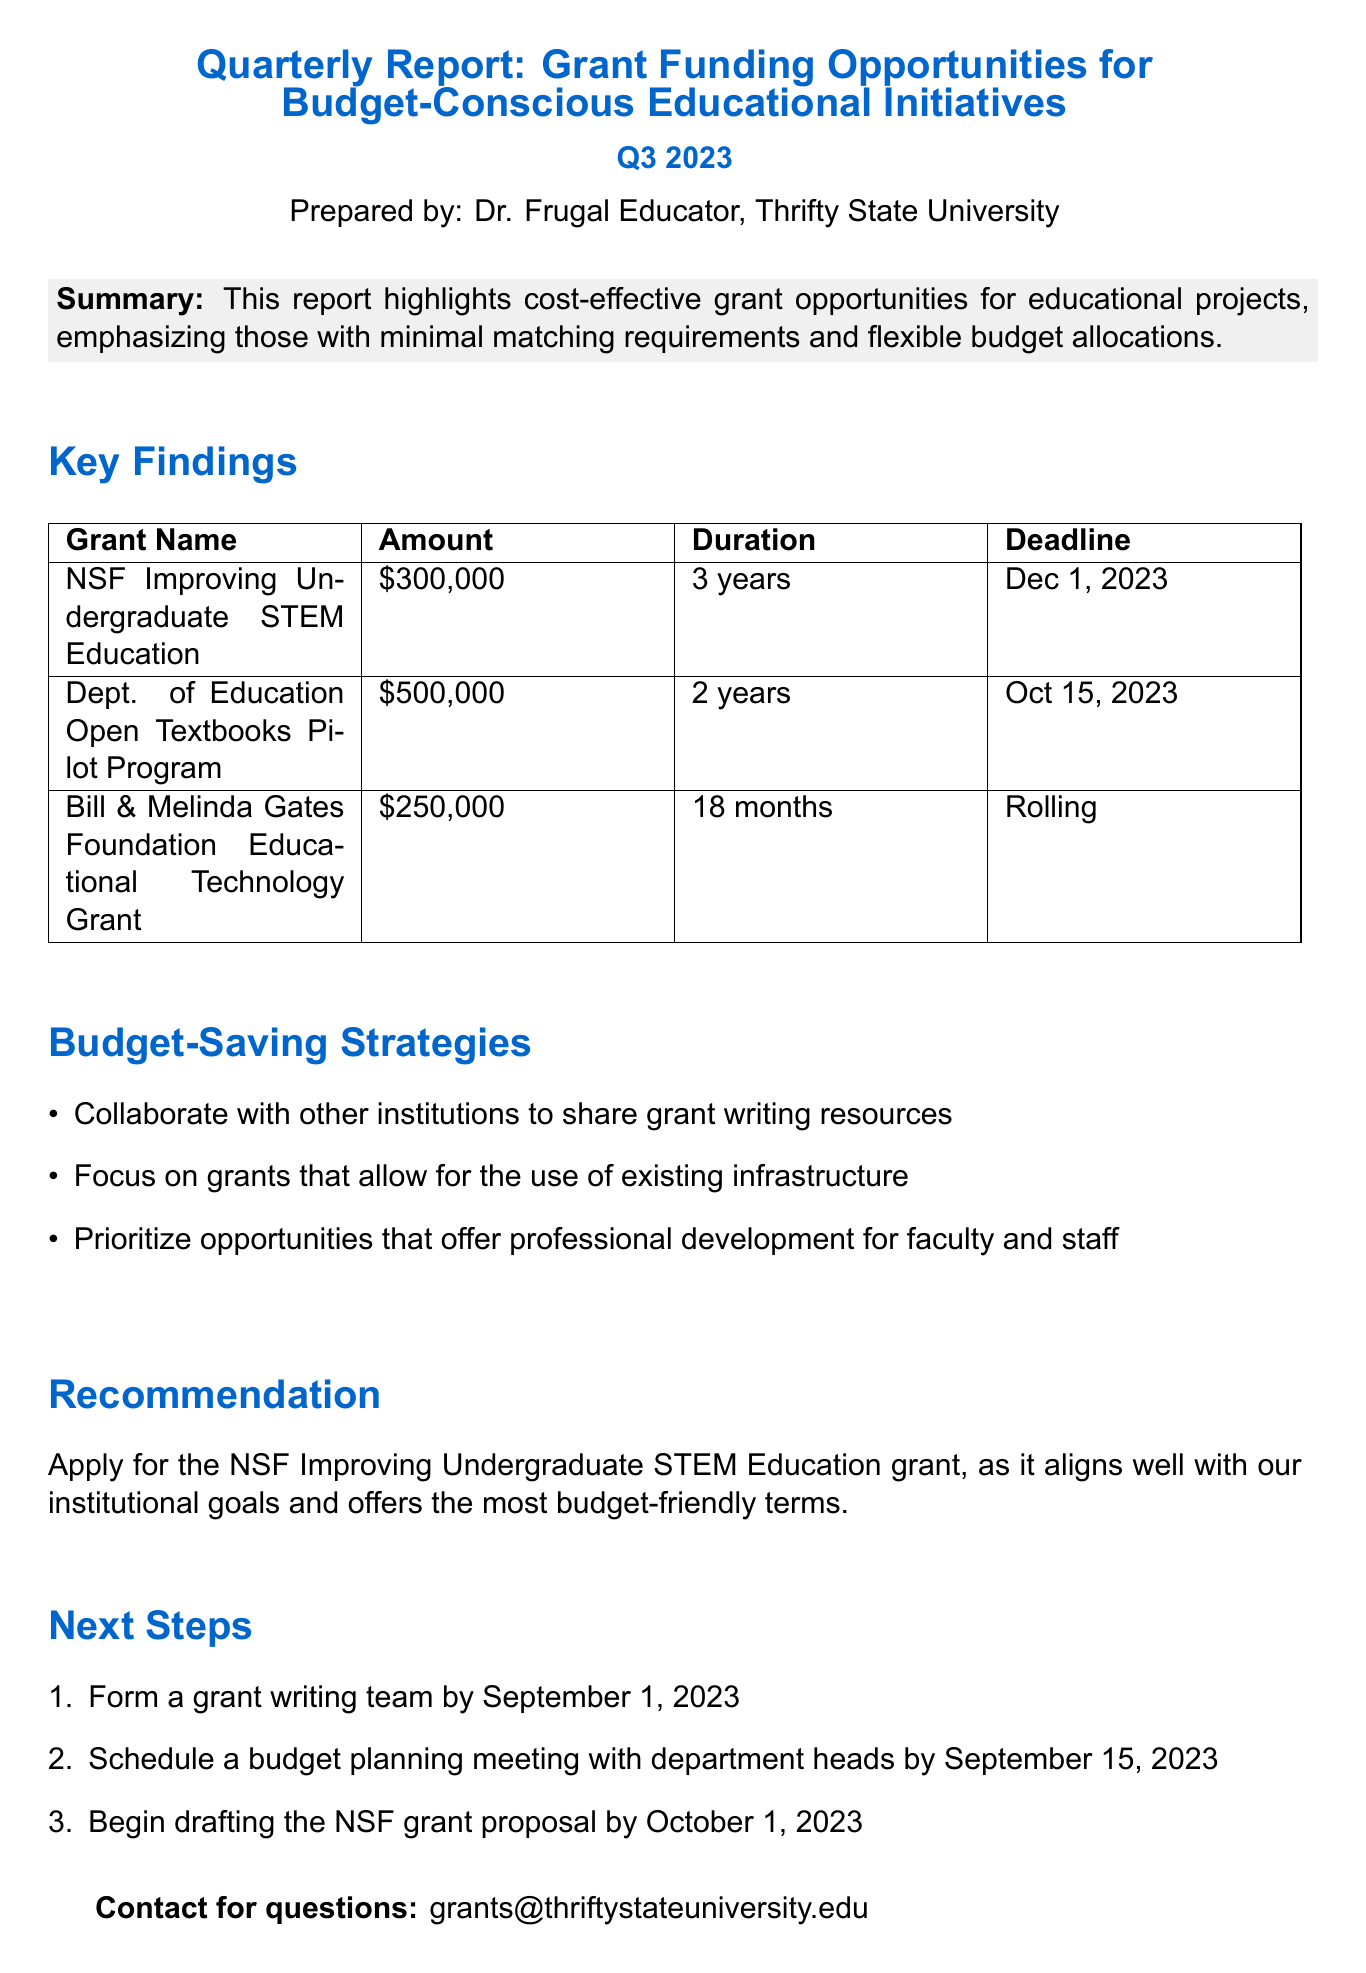What is the title of the report? The title of the report is provided in the first section of the document, stating the focus on grant funding opportunities for educational initiatives.
Answer: Quarterly Report: Grant Funding Opportunities for Budget-Conscious Educational Initiatives Who prepared the report? The name of the person who prepared the report is specified in the document, indicating their role in the creation of the report.
Answer: Dr. Frugal Educator What is the application deadline for the Department of Education Open Textbooks Pilot Program? The document lists specific application deadlines for each grant, highlighting the critical dates for applications.
Answer: October 15, 2023 How much funding is available from the National Science Foundation grant? The document outlines the amount of funding available for various grants, particularly highlighting the NSF grant amount.
Answer: $300,000 What is one of the budget-friendly features of the Bill & Melinda Gates Foundation Educational Technology Grant? The document describes features of each grant that make them budget-friendly, particularly focusing on resource reallocation.
Answer: Allows for reallocation of existing resources What is the recommended action in the report? The recommendation section of the document provides guidance on which grant to pursue, reflecting the alignment with institutional goals.
Answer: Apply for the NSF Improving Undergraduate STEM Education grant How many budget-saving strategies are listed? The report includes a section outlining strategies, providing a count of how many strategies are recommended for budget-conscious initiatives.
Answer: 3 When should the grant writing team be formed? The next steps section details dates for actions to be taken, including forming the grant writing team.
Answer: September 1, 2023 What is the duration of the Department of Education Open Textbooks Pilot Program? The document provides specific durations for each grant, each affecting the project's timeline and planning.
Answer: 2 years 